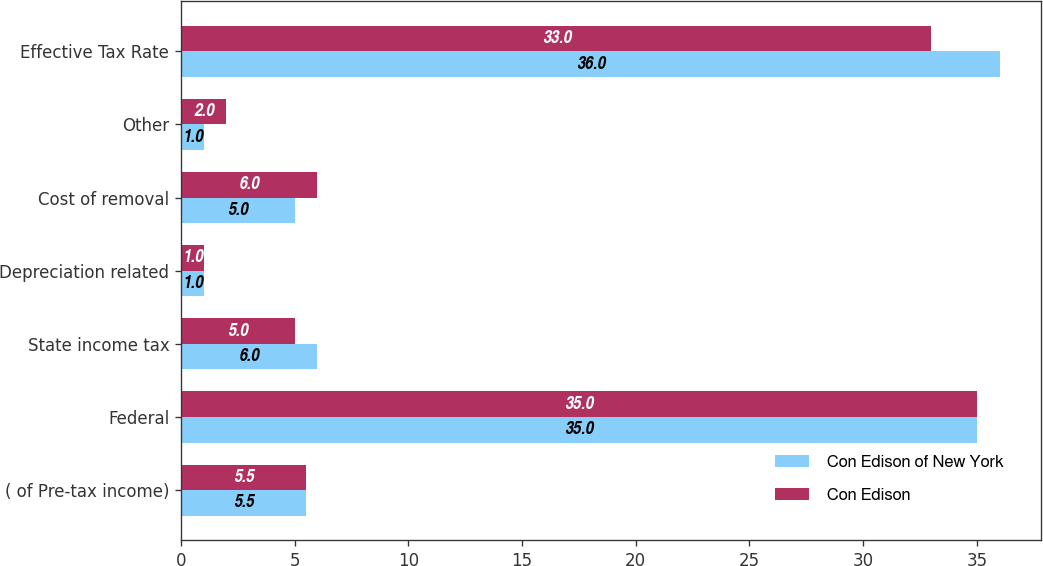Convert chart. <chart><loc_0><loc_0><loc_500><loc_500><stacked_bar_chart><ecel><fcel>( of Pre-tax income)<fcel>Federal<fcel>State income tax<fcel>Depreciation related<fcel>Cost of removal<fcel>Other<fcel>Effective Tax Rate<nl><fcel>Con Edison of New York<fcel>5.5<fcel>35<fcel>6<fcel>1<fcel>5<fcel>1<fcel>36<nl><fcel>Con Edison<fcel>5.5<fcel>35<fcel>5<fcel>1<fcel>6<fcel>2<fcel>33<nl></chart> 